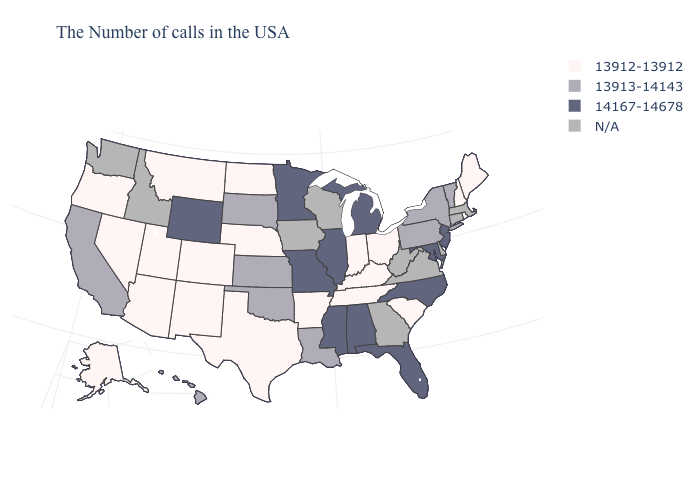Name the states that have a value in the range N/A?
Quick response, please. Massachusetts, Connecticut, Delaware, Virginia, West Virginia, Georgia, Wisconsin, Iowa, Idaho, Washington. How many symbols are there in the legend?
Concise answer only. 4. Name the states that have a value in the range 13912-13912?
Keep it brief. Maine, Rhode Island, New Hampshire, South Carolina, Ohio, Kentucky, Indiana, Tennessee, Arkansas, Nebraska, Texas, North Dakota, Colorado, New Mexico, Utah, Montana, Arizona, Nevada, Oregon, Alaska. Name the states that have a value in the range 13913-14143?
Write a very short answer. Vermont, New York, Pennsylvania, Louisiana, Kansas, Oklahoma, South Dakota, California, Hawaii. Does the first symbol in the legend represent the smallest category?
Quick response, please. Yes. Name the states that have a value in the range 13912-13912?
Keep it brief. Maine, Rhode Island, New Hampshire, South Carolina, Ohio, Kentucky, Indiana, Tennessee, Arkansas, Nebraska, Texas, North Dakota, Colorado, New Mexico, Utah, Montana, Arizona, Nevada, Oregon, Alaska. Name the states that have a value in the range 14167-14678?
Concise answer only. New Jersey, Maryland, North Carolina, Florida, Michigan, Alabama, Illinois, Mississippi, Missouri, Minnesota, Wyoming. Which states hav the highest value in the Northeast?
Keep it brief. New Jersey. Name the states that have a value in the range N/A?
Write a very short answer. Massachusetts, Connecticut, Delaware, Virginia, West Virginia, Georgia, Wisconsin, Iowa, Idaho, Washington. Name the states that have a value in the range 13912-13912?
Be succinct. Maine, Rhode Island, New Hampshire, South Carolina, Ohio, Kentucky, Indiana, Tennessee, Arkansas, Nebraska, Texas, North Dakota, Colorado, New Mexico, Utah, Montana, Arizona, Nevada, Oregon, Alaska. How many symbols are there in the legend?
Concise answer only. 4. What is the lowest value in states that border Michigan?
Concise answer only. 13912-13912. 